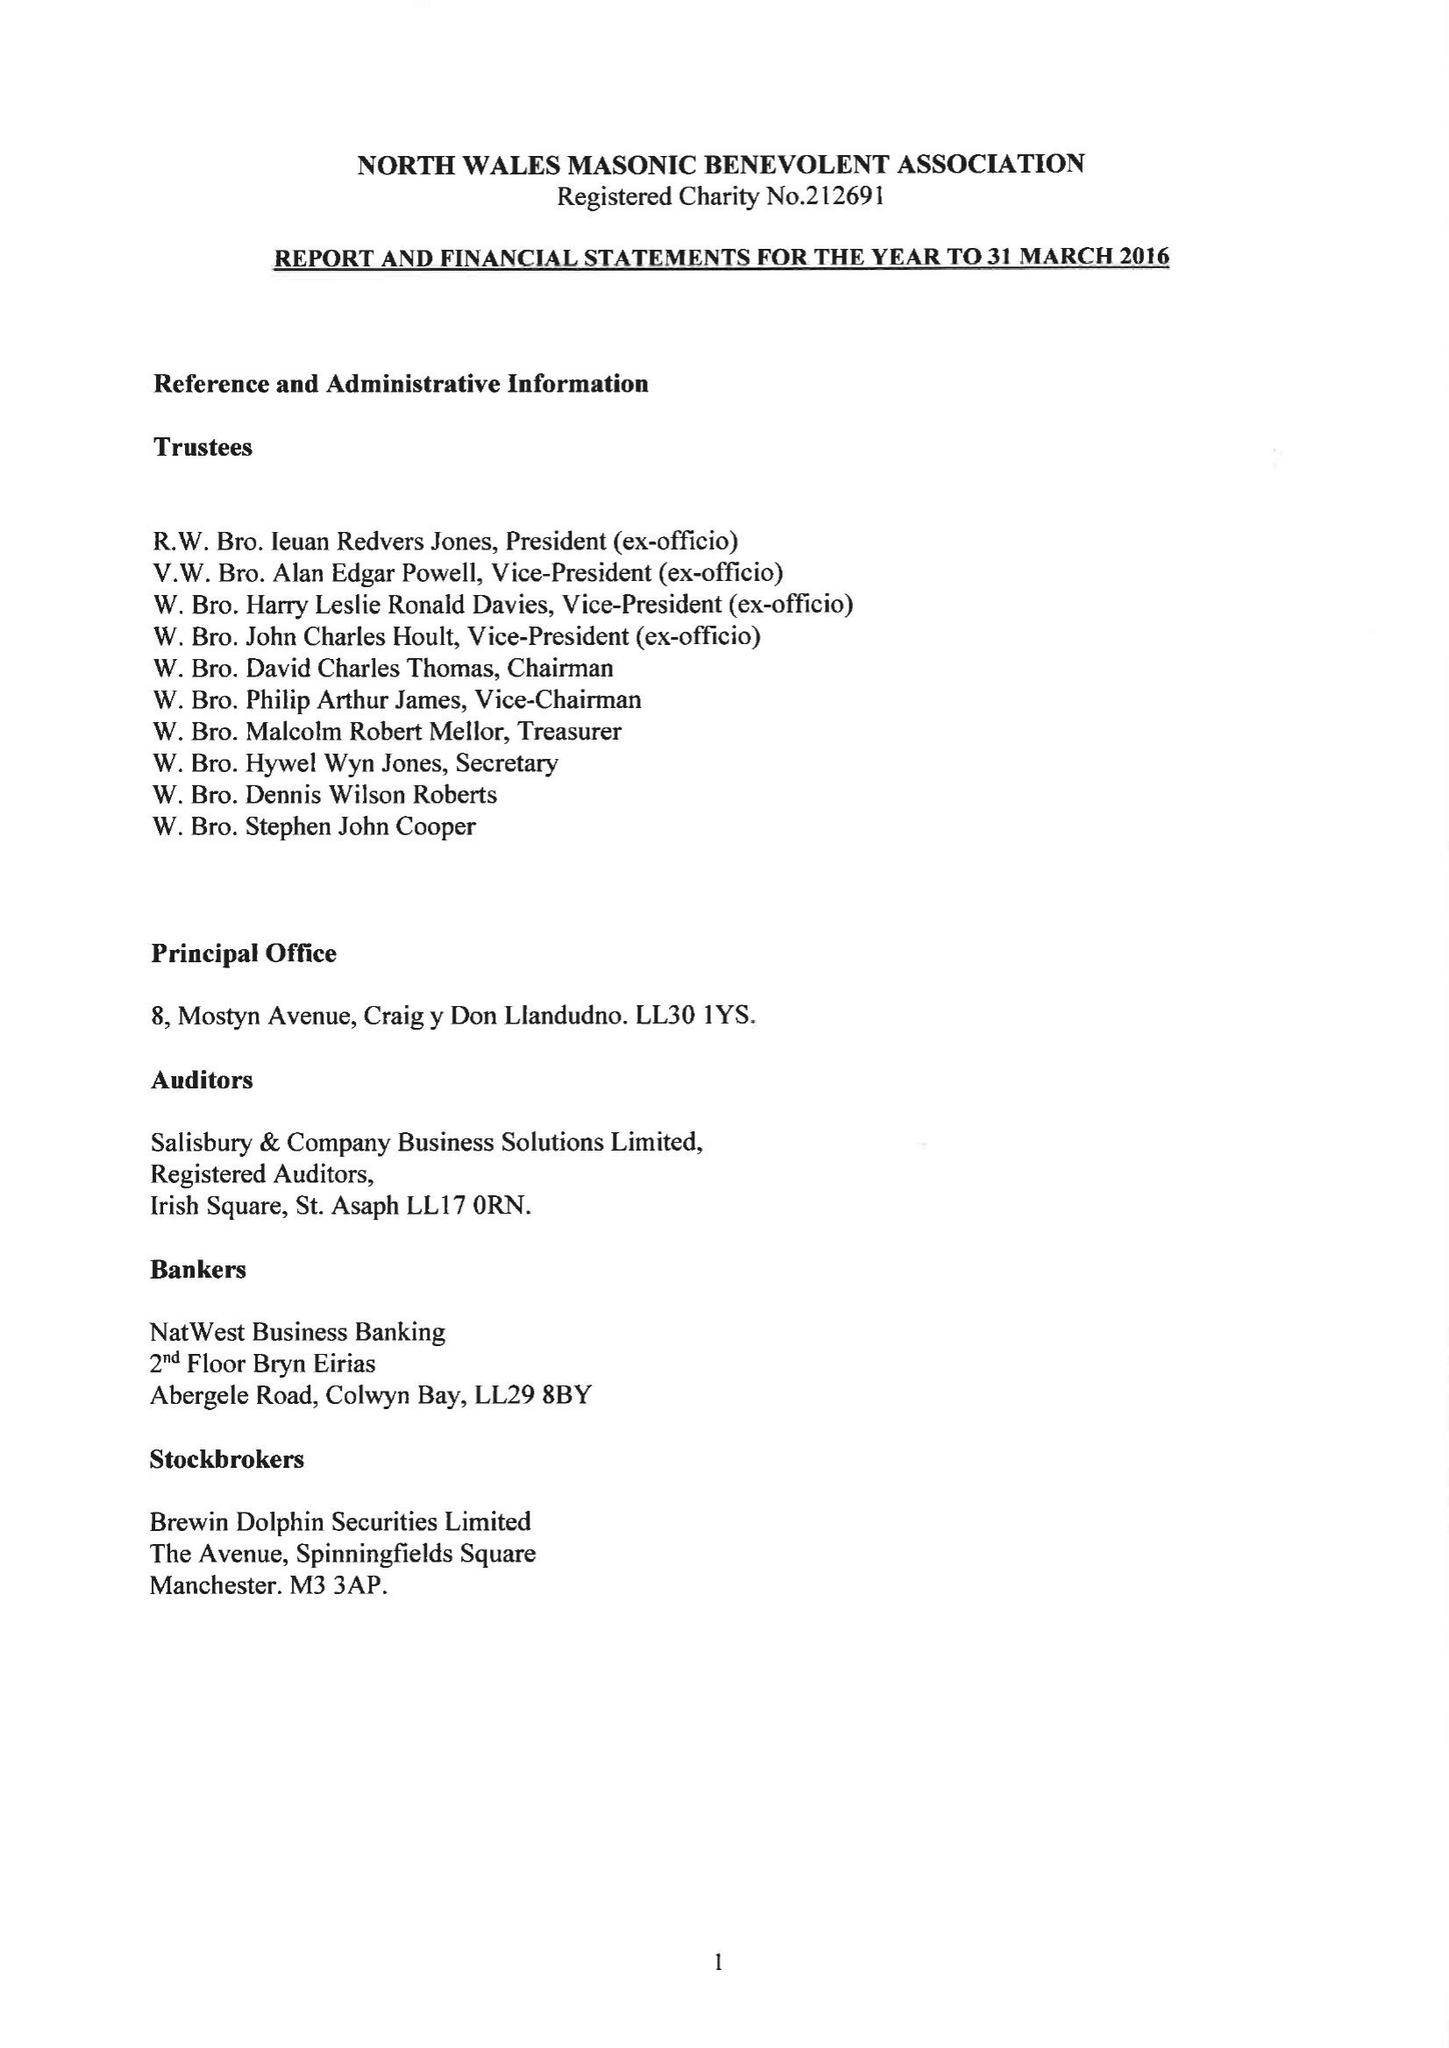What is the value for the charity_number?
Answer the question using a single word or phrase. 212691 